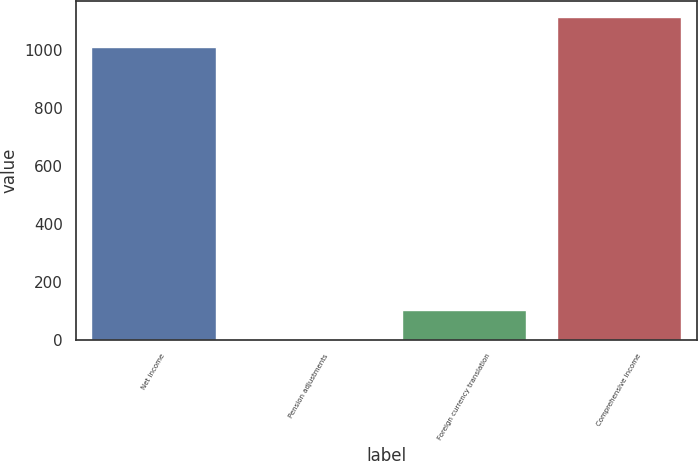Convert chart. <chart><loc_0><loc_0><loc_500><loc_500><bar_chart><fcel>Net income<fcel>Pension adjustments<fcel>Foreign currency translation<fcel>Comprehensive income<nl><fcel>1010.2<fcel>0.7<fcel>101.89<fcel>1111.39<nl></chart> 